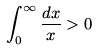Convert formula to latex. <formula><loc_0><loc_0><loc_500><loc_500>\int _ { 0 } ^ { \infty } \frac { d x } { x } > 0</formula> 